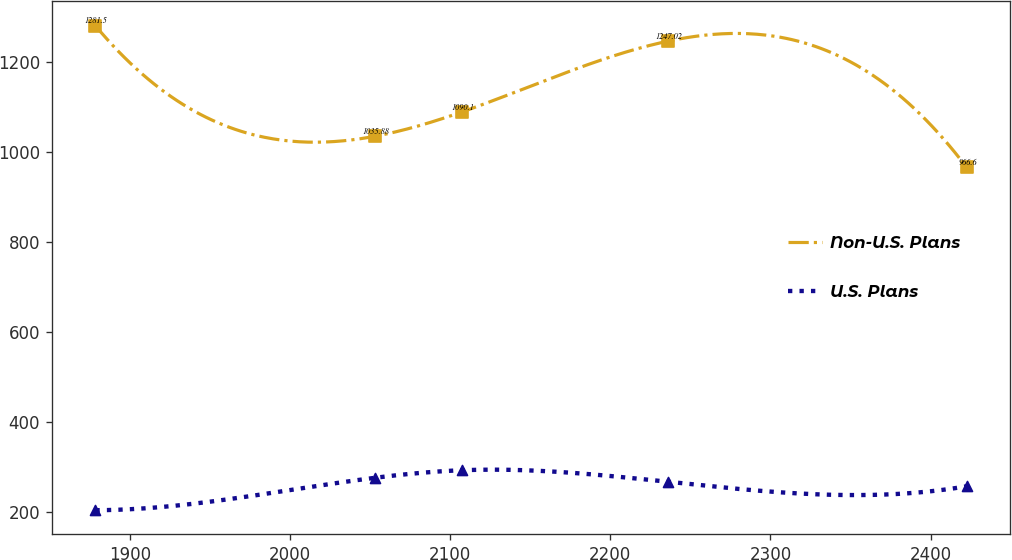Convert chart. <chart><loc_0><loc_0><loc_500><loc_500><line_chart><ecel><fcel>Non-U.S. Plans<fcel>U.S. Plans<nl><fcel>1878.36<fcel>1281.5<fcel>204.69<nl><fcel>2053.13<fcel>1035.88<fcel>276.79<nl><fcel>2107.55<fcel>1090.1<fcel>293.57<nl><fcel>2235.81<fcel>1247.02<fcel>267.9<nl><fcel>2422.53<fcel>966.6<fcel>257.82<nl></chart> 